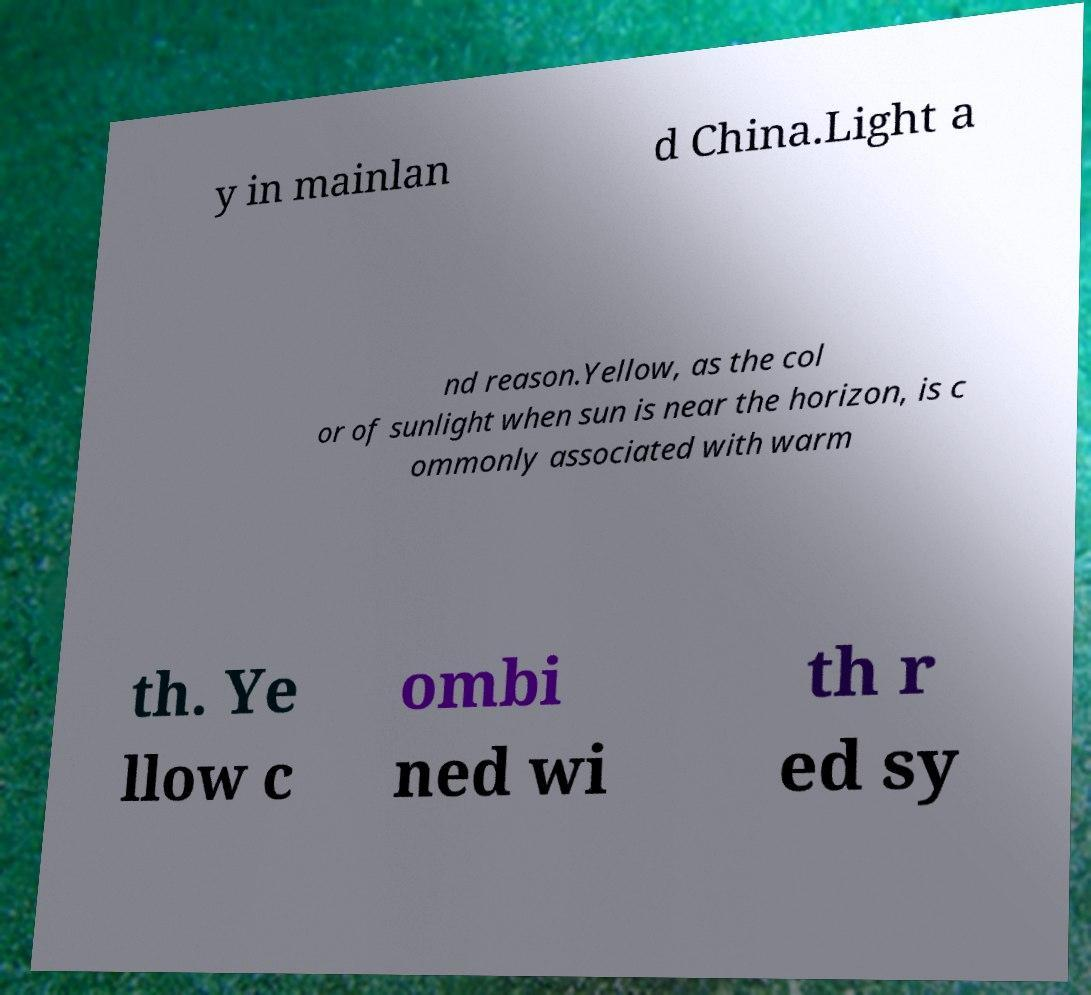I need the written content from this picture converted into text. Can you do that? y in mainlan d China.Light a nd reason.Yellow, as the col or of sunlight when sun is near the horizon, is c ommonly associated with warm th. Ye llow c ombi ned wi th r ed sy 